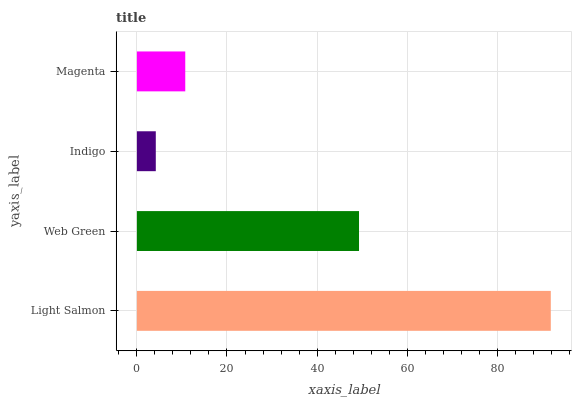Is Indigo the minimum?
Answer yes or no. Yes. Is Light Salmon the maximum?
Answer yes or no. Yes. Is Web Green the minimum?
Answer yes or no. No. Is Web Green the maximum?
Answer yes or no. No. Is Light Salmon greater than Web Green?
Answer yes or no. Yes. Is Web Green less than Light Salmon?
Answer yes or no. Yes. Is Web Green greater than Light Salmon?
Answer yes or no. No. Is Light Salmon less than Web Green?
Answer yes or no. No. Is Web Green the high median?
Answer yes or no. Yes. Is Magenta the low median?
Answer yes or no. Yes. Is Indigo the high median?
Answer yes or no. No. Is Web Green the low median?
Answer yes or no. No. 